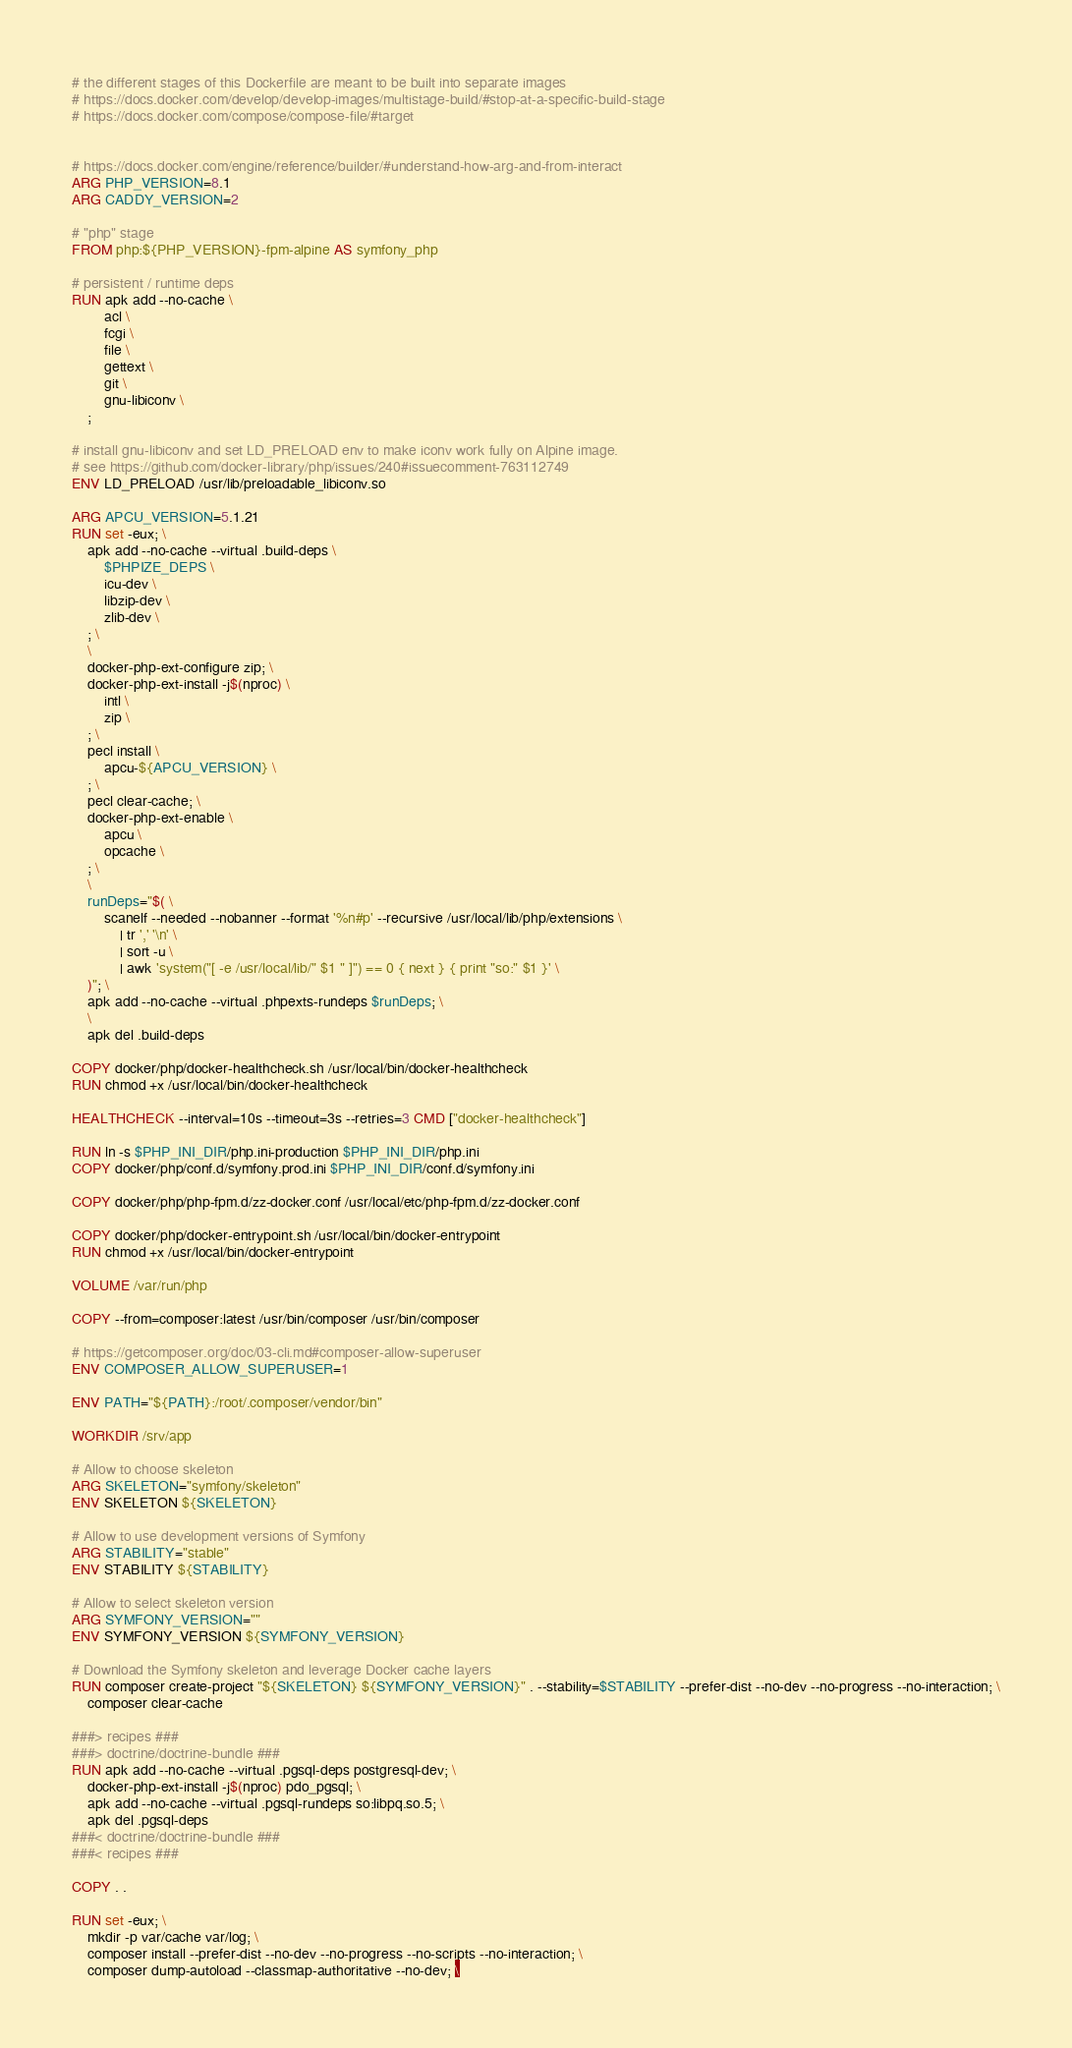Convert code to text. <code><loc_0><loc_0><loc_500><loc_500><_Dockerfile_># the different stages of this Dockerfile are meant to be built into separate images
# https://docs.docker.com/develop/develop-images/multistage-build/#stop-at-a-specific-build-stage
# https://docs.docker.com/compose/compose-file/#target


# https://docs.docker.com/engine/reference/builder/#understand-how-arg-and-from-interact
ARG PHP_VERSION=8.1
ARG CADDY_VERSION=2

# "php" stage
FROM php:${PHP_VERSION}-fpm-alpine AS symfony_php

# persistent / runtime deps
RUN apk add --no-cache \
		acl \
		fcgi \
		file \
		gettext \
		git \
		gnu-libiconv \
	;

# install gnu-libiconv and set LD_PRELOAD env to make iconv work fully on Alpine image.
# see https://github.com/docker-library/php/issues/240#issuecomment-763112749
ENV LD_PRELOAD /usr/lib/preloadable_libiconv.so

ARG APCU_VERSION=5.1.21
RUN set -eux; \
	apk add --no-cache --virtual .build-deps \
		$PHPIZE_DEPS \
		icu-dev \
		libzip-dev \
		zlib-dev \
	; \
	\
	docker-php-ext-configure zip; \
	docker-php-ext-install -j$(nproc) \
		intl \
		zip \
	; \
	pecl install \
		apcu-${APCU_VERSION} \
	; \
	pecl clear-cache; \
	docker-php-ext-enable \
		apcu \
		opcache \
	; \
	\
	runDeps="$( \
		scanelf --needed --nobanner --format '%n#p' --recursive /usr/local/lib/php/extensions \
			| tr ',' '\n' \
			| sort -u \
			| awk 'system("[ -e /usr/local/lib/" $1 " ]") == 0 { next } { print "so:" $1 }' \
	)"; \
	apk add --no-cache --virtual .phpexts-rundeps $runDeps; \
	\
	apk del .build-deps

COPY docker/php/docker-healthcheck.sh /usr/local/bin/docker-healthcheck
RUN chmod +x /usr/local/bin/docker-healthcheck

HEALTHCHECK --interval=10s --timeout=3s --retries=3 CMD ["docker-healthcheck"]

RUN ln -s $PHP_INI_DIR/php.ini-production $PHP_INI_DIR/php.ini
COPY docker/php/conf.d/symfony.prod.ini $PHP_INI_DIR/conf.d/symfony.ini

COPY docker/php/php-fpm.d/zz-docker.conf /usr/local/etc/php-fpm.d/zz-docker.conf

COPY docker/php/docker-entrypoint.sh /usr/local/bin/docker-entrypoint
RUN chmod +x /usr/local/bin/docker-entrypoint

VOLUME /var/run/php

COPY --from=composer:latest /usr/bin/composer /usr/bin/composer

# https://getcomposer.org/doc/03-cli.md#composer-allow-superuser
ENV COMPOSER_ALLOW_SUPERUSER=1

ENV PATH="${PATH}:/root/.composer/vendor/bin"

WORKDIR /srv/app

# Allow to choose skeleton
ARG SKELETON="symfony/skeleton"
ENV SKELETON ${SKELETON}

# Allow to use development versions of Symfony
ARG STABILITY="stable"
ENV STABILITY ${STABILITY}

# Allow to select skeleton version
ARG SYMFONY_VERSION=""
ENV SYMFONY_VERSION ${SYMFONY_VERSION}

# Download the Symfony skeleton and leverage Docker cache layers
RUN composer create-project "${SKELETON} ${SYMFONY_VERSION}" . --stability=$STABILITY --prefer-dist --no-dev --no-progress --no-interaction; \
	composer clear-cache

###> recipes ###
###> doctrine/doctrine-bundle ###
RUN apk add --no-cache --virtual .pgsql-deps postgresql-dev; \
	docker-php-ext-install -j$(nproc) pdo_pgsql; \
	apk add --no-cache --virtual .pgsql-rundeps so:libpq.so.5; \
	apk del .pgsql-deps
###< doctrine/doctrine-bundle ###
###< recipes ###

COPY . .

RUN set -eux; \
	mkdir -p var/cache var/log; \
	composer install --prefer-dist --no-dev --no-progress --no-scripts --no-interaction; \
	composer dump-autoload --classmap-authoritative --no-dev; \</code> 